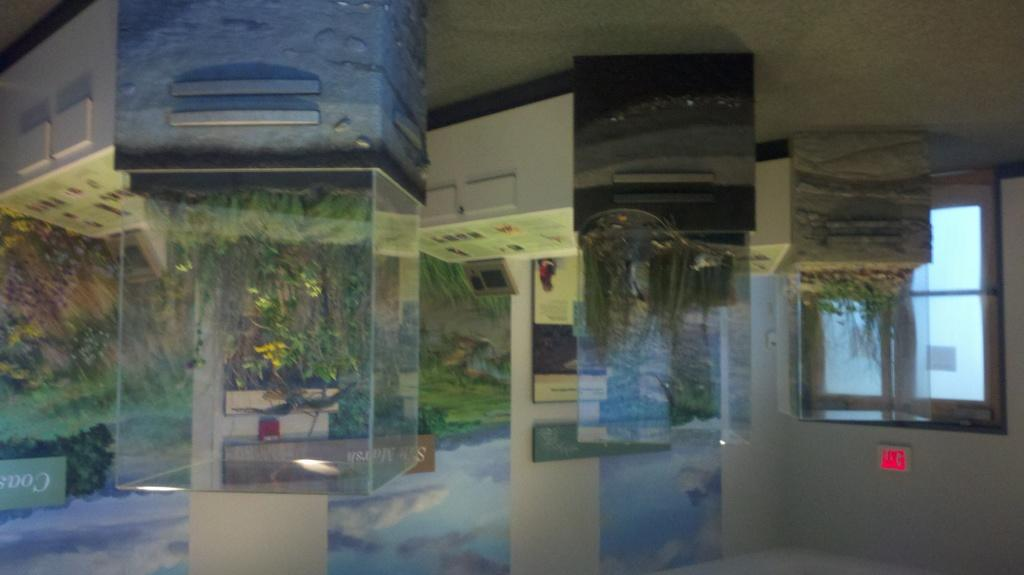What type of glasses are visible in the image? There are transparent glasses in the image. What type of natural vegetation is present in the image? There are trees and plants in the image. What type of structure is present in the image? There is a wall in the image. What type of architectural feature is present in the image? There are windows in the image. Where is the toy bat located in the image? There is no toy bat present in the image. What type of creature is shown playing with the toy bat in the image? There is no creature or toy bat present in the image. 